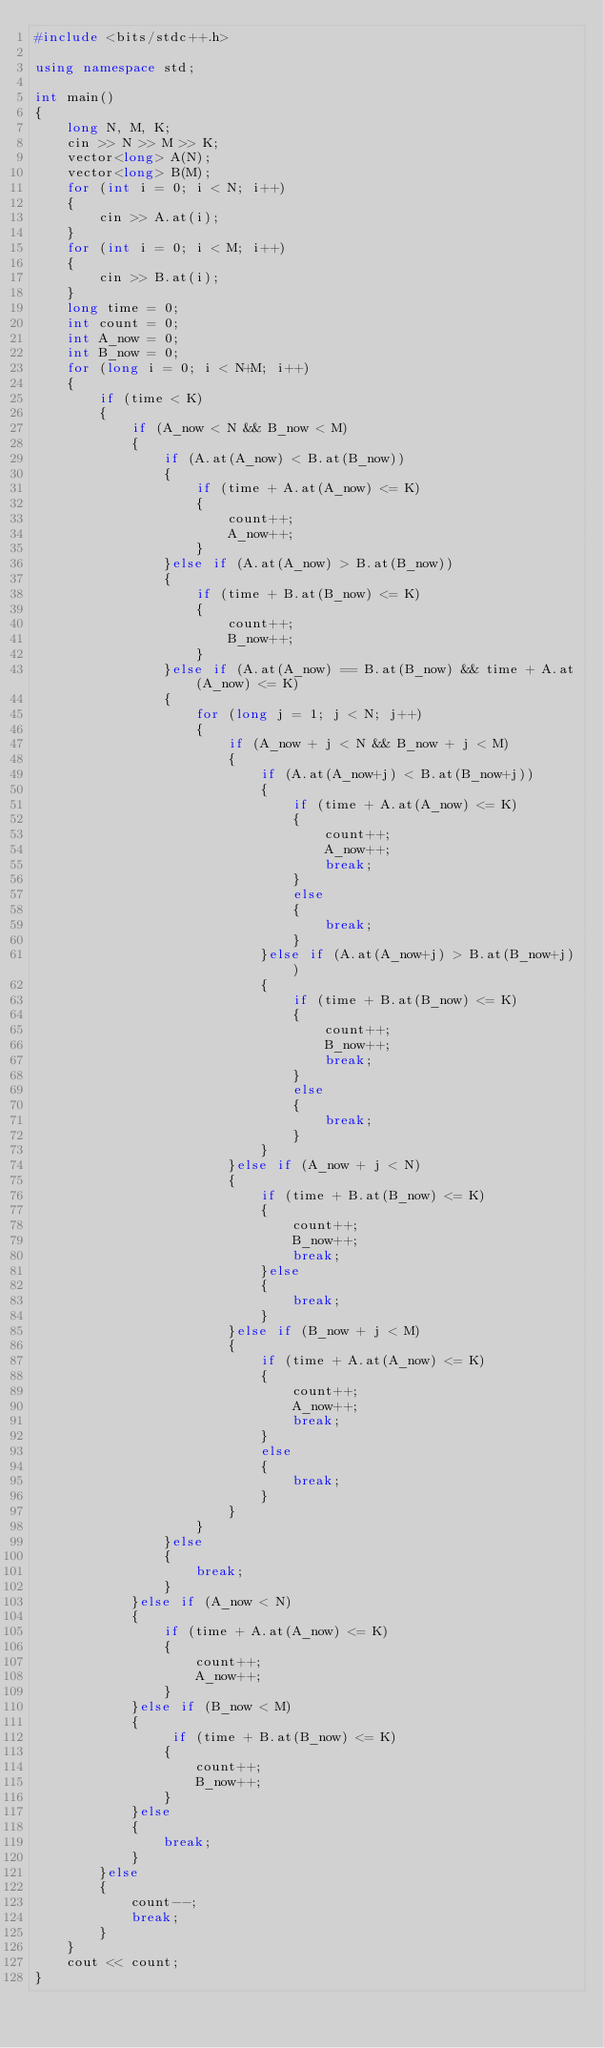Convert code to text. <code><loc_0><loc_0><loc_500><loc_500><_C++_>#include <bits/stdc++.h>
 
using namespace std;
 
int main()
{
    long N, M, K;
    cin >> N >> M >> K;
    vector<long> A(N);
    vector<long> B(M);
    for (int i = 0; i < N; i++)
    {
        cin >> A.at(i);
    }
    for (int i = 0; i < M; i++)
    {
        cin >> B.at(i);
    }
    long time = 0;
    int count = 0;
    int A_now = 0;
    int B_now = 0;
    for (long i = 0; i < N+M; i++)
    {
        if (time < K)
        {
            if (A_now < N && B_now < M)
            {
                if (A.at(A_now) < B.at(B_now))
                {
                    if (time + A.at(A_now) <= K)
                    {
                        count++;
                        A_now++;
                    }
                }else if (A.at(A_now) > B.at(B_now))
                {
                    if (time + B.at(B_now) <= K)
                    {
                        count++;
                        B_now++;
                    }
                }else if (A.at(A_now) == B.at(B_now) && time + A.at(A_now) <= K)
                {
                    for (long j = 1; j < N; j++)
                    {
                        if (A_now + j < N && B_now + j < M)
                        {
                            if (A.at(A_now+j) < B.at(B_now+j))
                            {
                                if (time + A.at(A_now) <= K)
                                {
                                    count++;
                                    A_now++;
                                    break;
                                }
                                else
                                {
                                    break;
                                }
                            }else if (A.at(A_now+j) > B.at(B_now+j))
                            {
                                if (time + B.at(B_now) <= K)
                                {
                                    count++;
                                    B_now++;
                                    break;
                                }
                                else
                                {
                                    break;
                                }
                            }
                        }else if (A_now + j < N)
                        {
                            if (time + B.at(B_now) <= K)
                            {
                                count++;
                                B_now++;
                                break;
                            }else
                            {
                                break;
                            }
                        }else if (B_now + j < M)
                        {
                            if (time + A.at(A_now) <= K)
                            {
                                count++;
                                A_now++;
                                break;
                            }
                            else
                            {
                                break;
                            }
                        }
                    }
                }else
                {
                    break;
                }
            }else if (A_now < N)
            {
                if (time + A.at(A_now) <= K)
                {
                    count++;
                    A_now++;
                }
            }else if (B_now < M)
            {
                 if (time + B.at(B_now) <= K)
                {
                    count++;
                    B_now++;
                }
            }else
            {
                break;
            }
        }else
        {
            count--;
            break;
        }
    }
    cout << count;
}</code> 